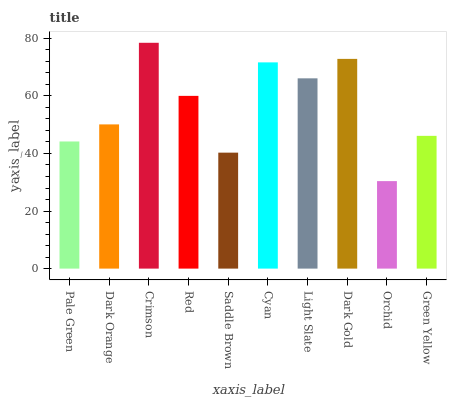Is Orchid the minimum?
Answer yes or no. Yes. Is Crimson the maximum?
Answer yes or no. Yes. Is Dark Orange the minimum?
Answer yes or no. No. Is Dark Orange the maximum?
Answer yes or no. No. Is Dark Orange greater than Pale Green?
Answer yes or no. Yes. Is Pale Green less than Dark Orange?
Answer yes or no. Yes. Is Pale Green greater than Dark Orange?
Answer yes or no. No. Is Dark Orange less than Pale Green?
Answer yes or no. No. Is Red the high median?
Answer yes or no. Yes. Is Dark Orange the low median?
Answer yes or no. Yes. Is Saddle Brown the high median?
Answer yes or no. No. Is Green Yellow the low median?
Answer yes or no. No. 